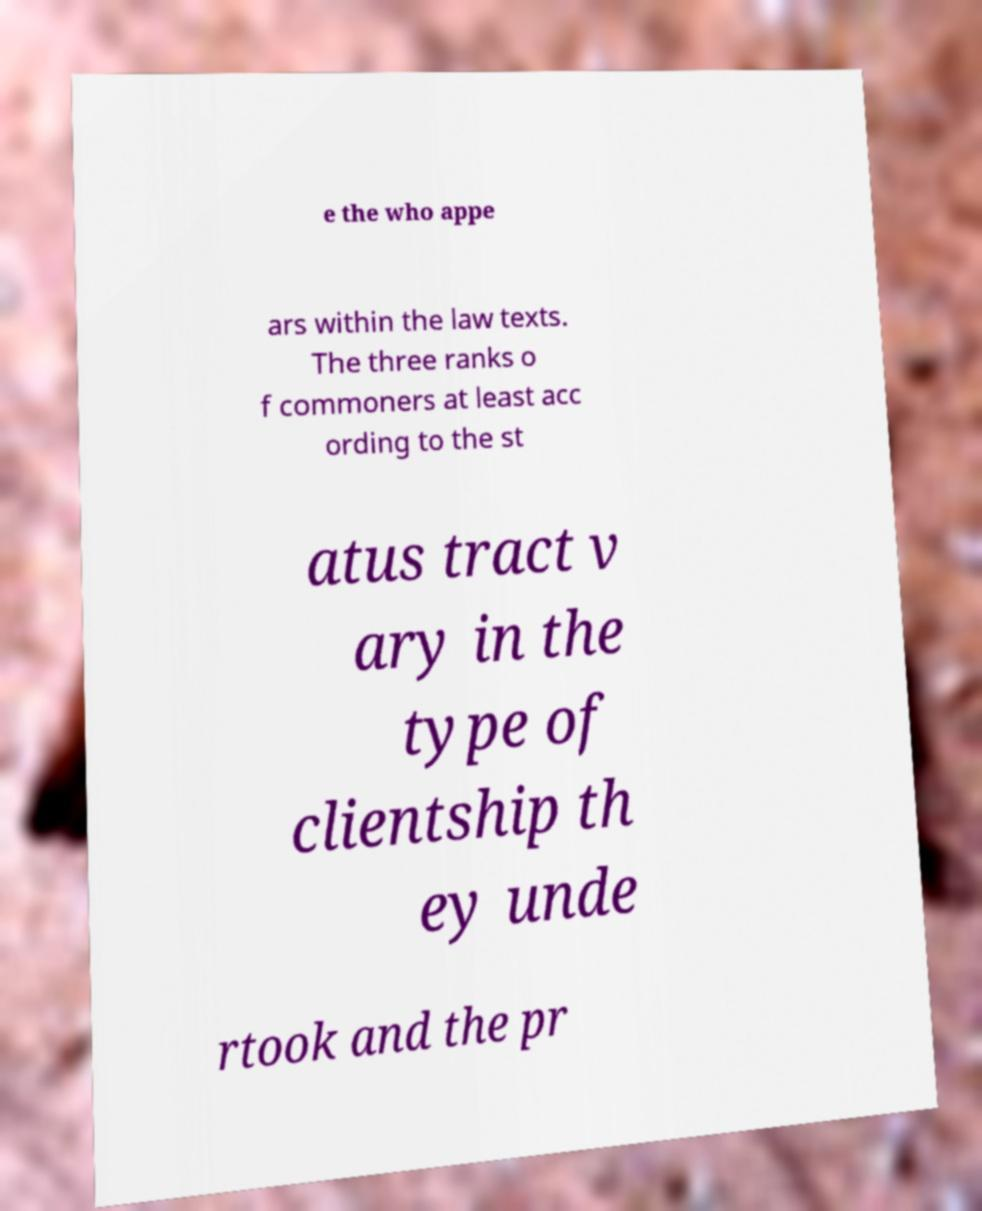There's text embedded in this image that I need extracted. Can you transcribe it verbatim? e the who appe ars within the law texts. The three ranks o f commoners at least acc ording to the st atus tract v ary in the type of clientship th ey unde rtook and the pr 